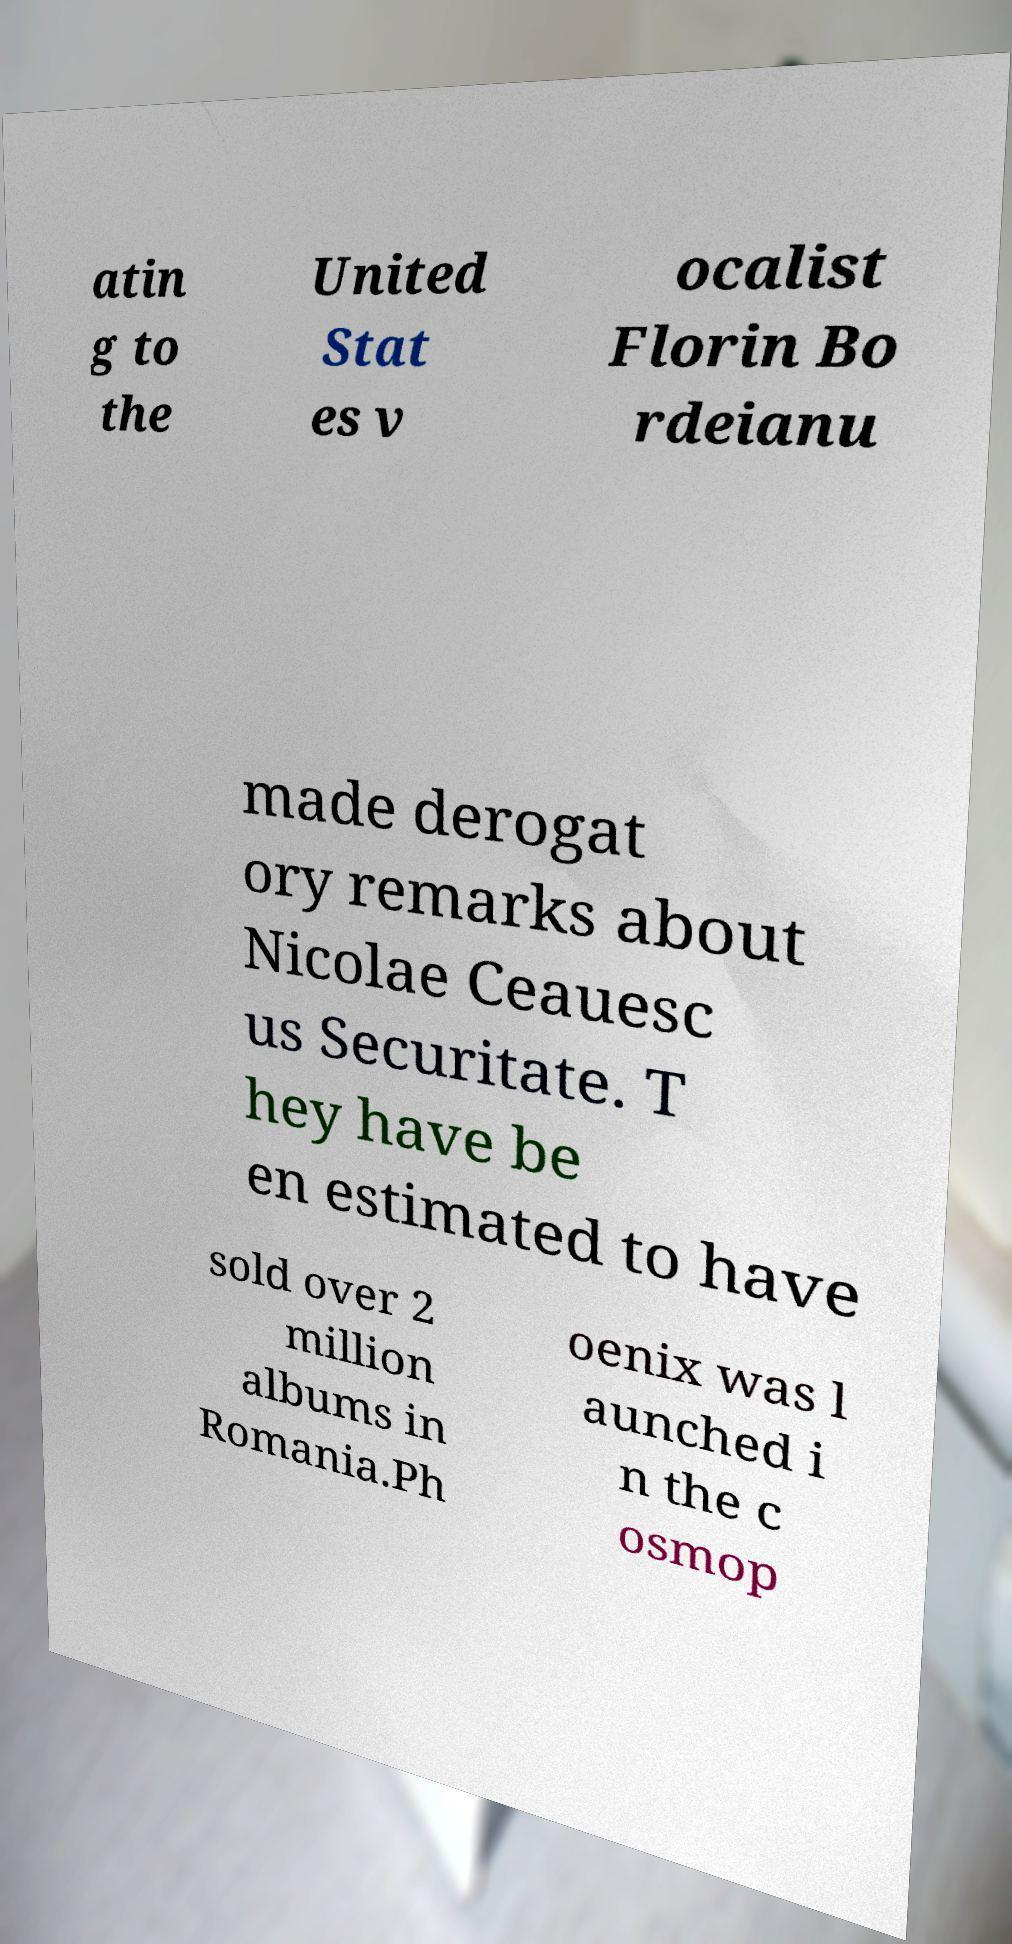What messages or text are displayed in this image? I need them in a readable, typed format. atin g to the United Stat es v ocalist Florin Bo rdeianu made derogat ory remarks about Nicolae Ceauesc us Securitate. T hey have be en estimated to have sold over 2 million albums in Romania.Ph oenix was l aunched i n the c osmop 